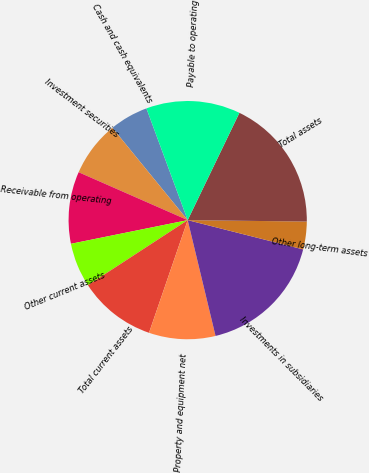<chart> <loc_0><loc_0><loc_500><loc_500><pie_chart><fcel>Cash and cash equivalents<fcel>Investment securities<fcel>Receivable from operating<fcel>Other current assets<fcel>Total current assets<fcel>Property and equipment net<fcel>Investments in subsidiaries<fcel>Other long-term assets<fcel>Total assets<fcel>Payable to operating<nl><fcel>5.26%<fcel>7.52%<fcel>9.77%<fcel>6.02%<fcel>10.53%<fcel>9.02%<fcel>17.29%<fcel>3.76%<fcel>18.04%<fcel>12.78%<nl></chart> 